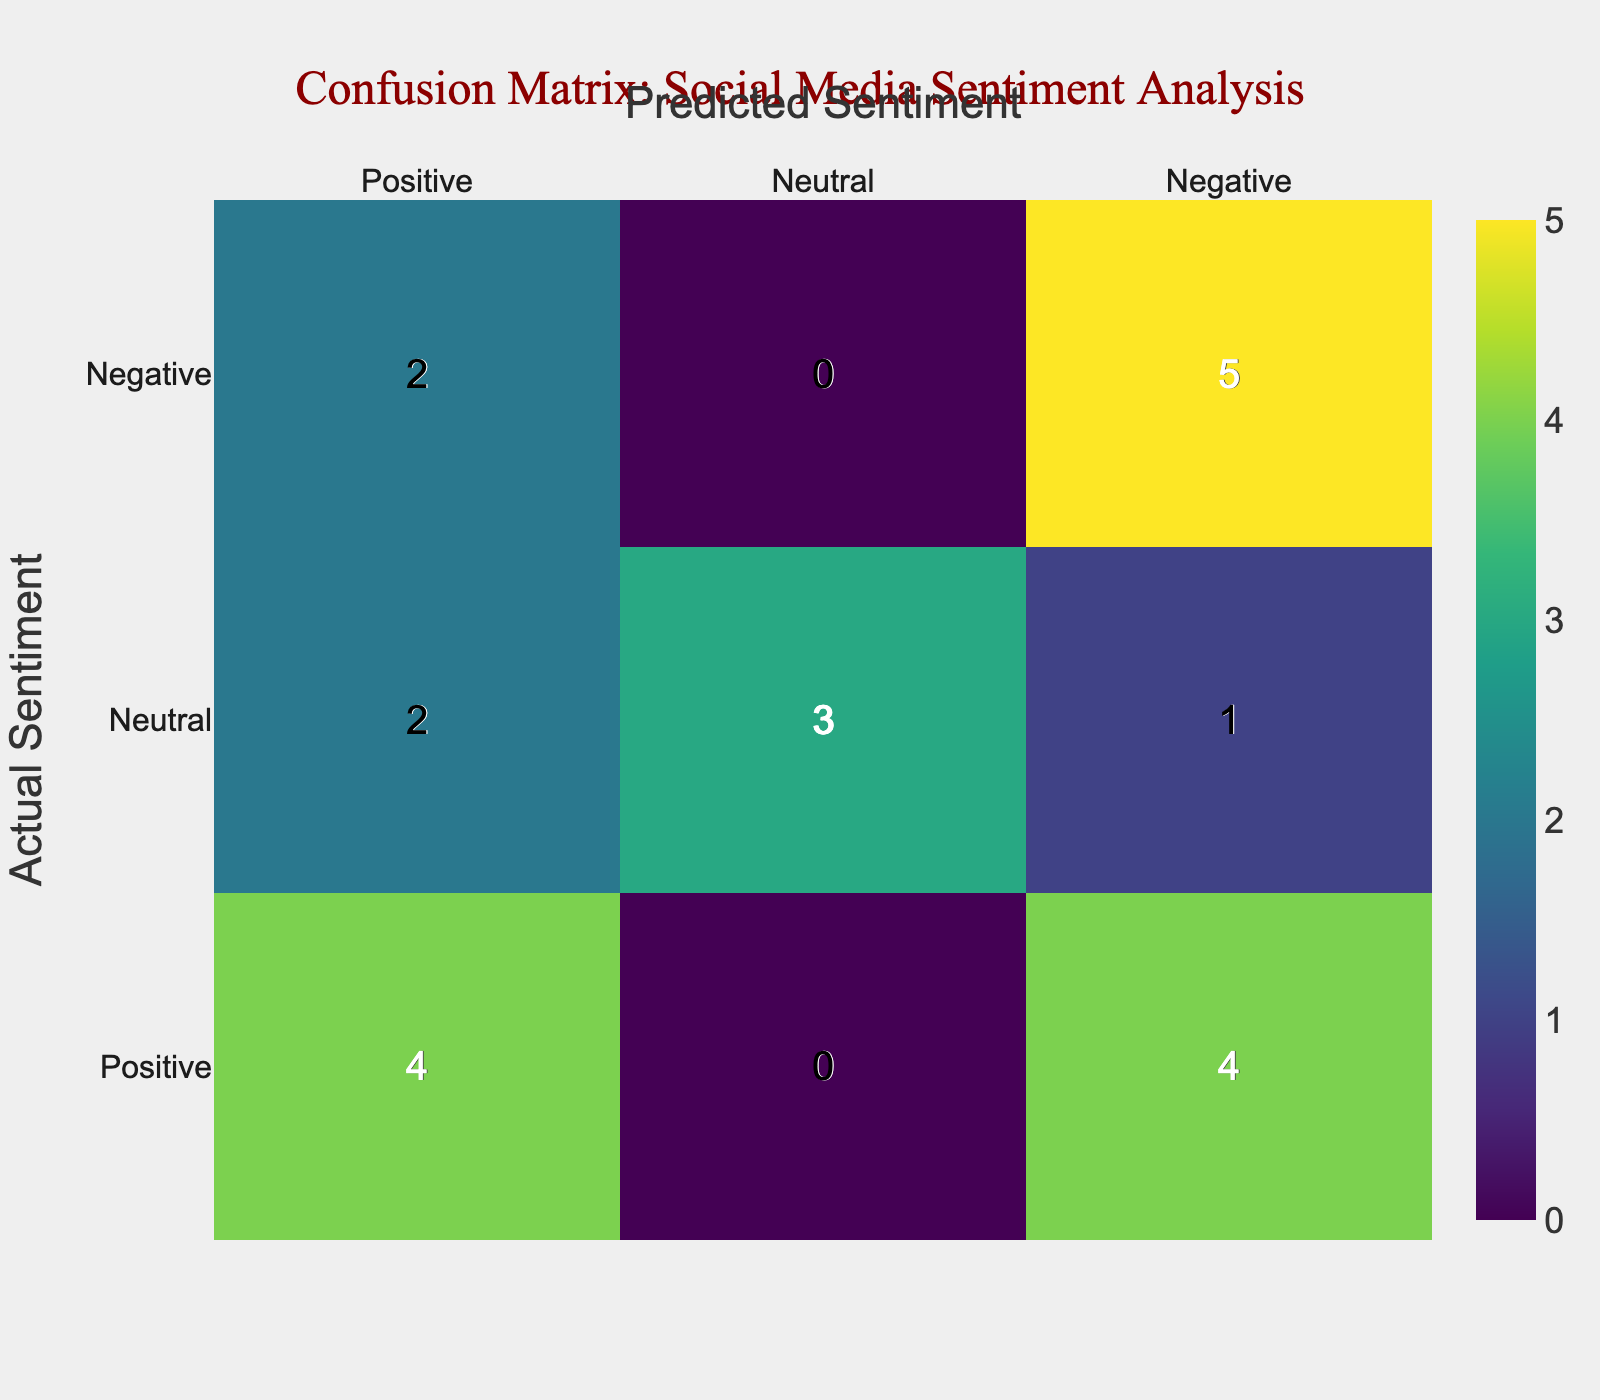What is the total number of actual positive sentiments? To find the total actual positive sentiments, we can look at the 'Actual Sentiment' row labeled 'Positive' in the confusion matrix. The total count for this row is the sum of all values across the row for 'Predicted Sentiment,' which is 5.
Answer: 5 What is the number of true negatives? The true negatives are found at the intersection of 'Negative' for both the actual and predictive sentiments. In the confusion matrix, this value shows 7, indicating there were 7 instances where the sentiment was predicted as negative and was actually negative.
Answer: 7 How many times was a neutral sentiment misclassified as positive? To find this, we look for the 'Neutral' row and 'Positive' column in the confusion matrix. The intersection reveals that there are 3 instances where neutrals were incorrectly predicted as positive.
Answer: 3 What is the overall accuracy of the sentiment predictions? The overall accuracy can be calculated by taking the sum of true positives and true negatives and dividing it by the total number of predictions. True positives (actual Positive and predicted Positive) are 5 and true negatives (actual Negative and predicted Negative) are 7, giving us 5 + 7 = 12. The total number of predictions is 20. Accuracy = 12/20 = 0.6 or 60%.
Answer: 60% Are there more instances of positive or negative sentiments predicted? To determine this, we sum up the predicted sentiments for positive and negative in the confusion matrix. For predicted positives, we find the counts: 5 + 1 (neutral predicted as positive) + 4 (actual positives predicted as negatives) = 10. For negatives, we find the counts: 7 (true negatives) + 1 (positive predicted as negative) + 2 (neutral predicting negative) = 10. Since both totals equal, there are the same instances for positive and negative sentiments predicted.
Answer: No What is the total count of misclassified positive sentiments? Misclassified positive sentiments include those that were predicted as neutral and negative. For the 'Positive' row, we have 5 positives misclassified as negatives and 1 as neutral. Adding these gives us 5 + 1 = 6 instances of misclassification.
Answer: 6 How many total neutral sentiments were correctly classified? The correct classification of neutral sentiments can be found in the confusion matrix at the intersection of 'Neutral' for both actual and predictive sentiments. The count here is 3, indicating that there were 3 instances accurately classified as neutral.
Answer: 3 What is the difference between the number of true positives and false positives? To find this difference, we identify the number of true positives (5) and false positives (unlike the true status, these are cases where negative or neutral are predicted positive). The false positives can be derived as 1 neutral and 4 negatives predicted as positive, giving us 5 in total. So, true positives (5) - false positives (5) = 0.
Answer: 0 What percentage of neutral actual sentiments were misclassified? We focus on the neutral sentiments in the 'Actual Sentiment' category. There are 4 neutral cases. Out of these, 1 was misclassified as negative and 3 as positive, giving a total of 4 misclassified. The misclassified percentage is calculated as (4 misclassified / 4 total neutral sentiments) * 100 = 100%.
Answer: 100% 